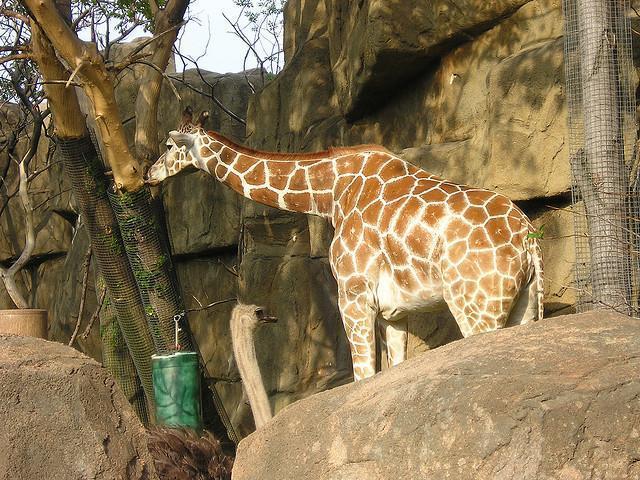How many giraffes can be seen?
Give a very brief answer. 1. 